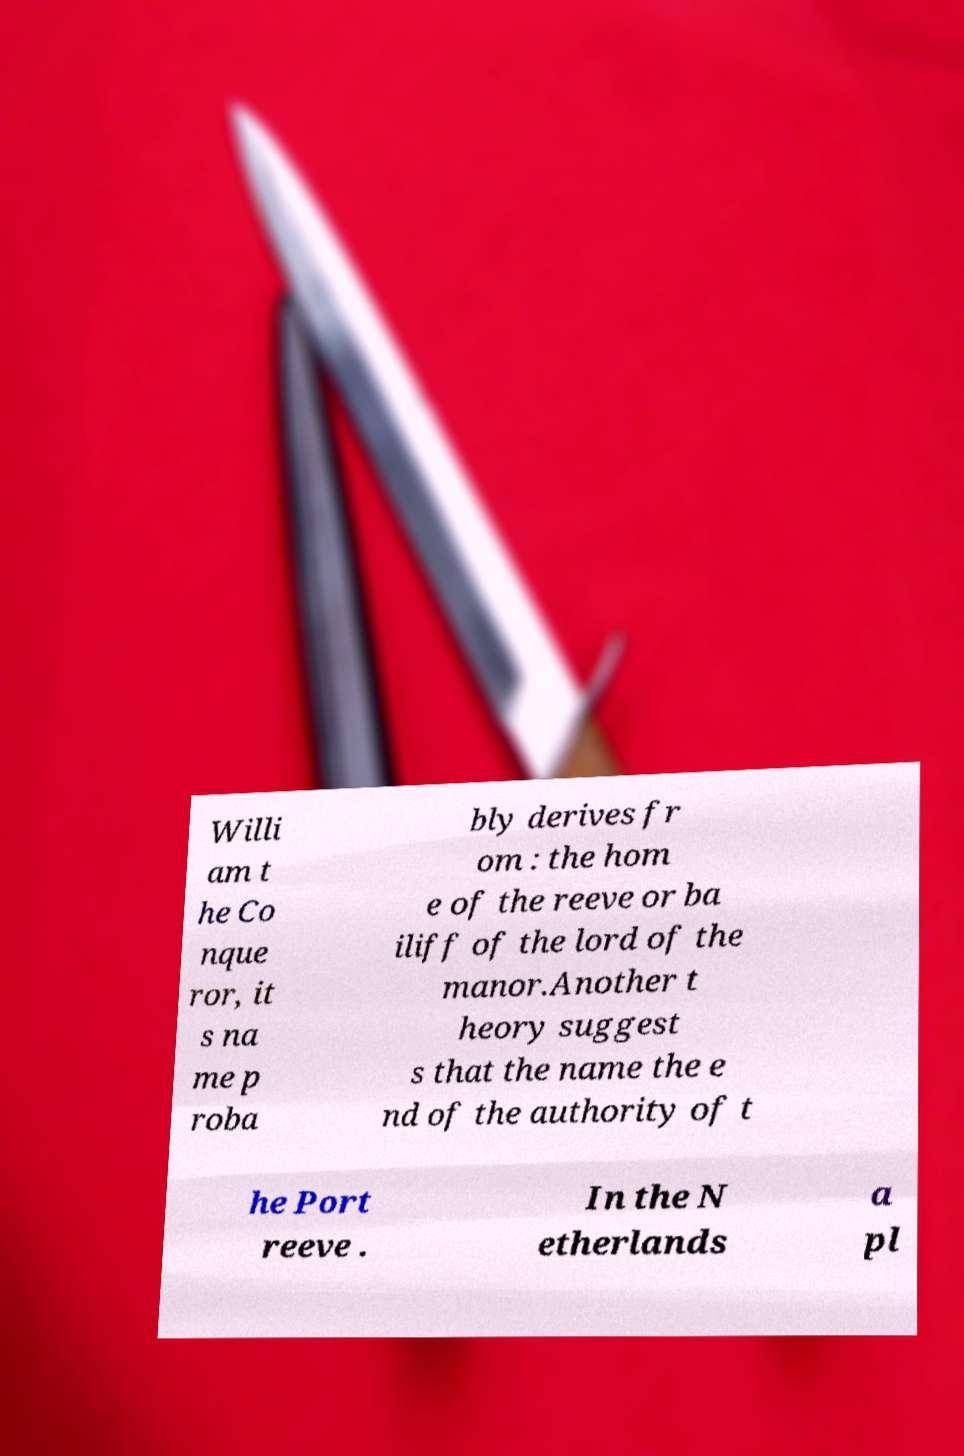There's text embedded in this image that I need extracted. Can you transcribe it verbatim? Willi am t he Co nque ror, it s na me p roba bly derives fr om : the hom e of the reeve or ba iliff of the lord of the manor.Another t heory suggest s that the name the e nd of the authority of t he Port reeve . In the N etherlands a pl 